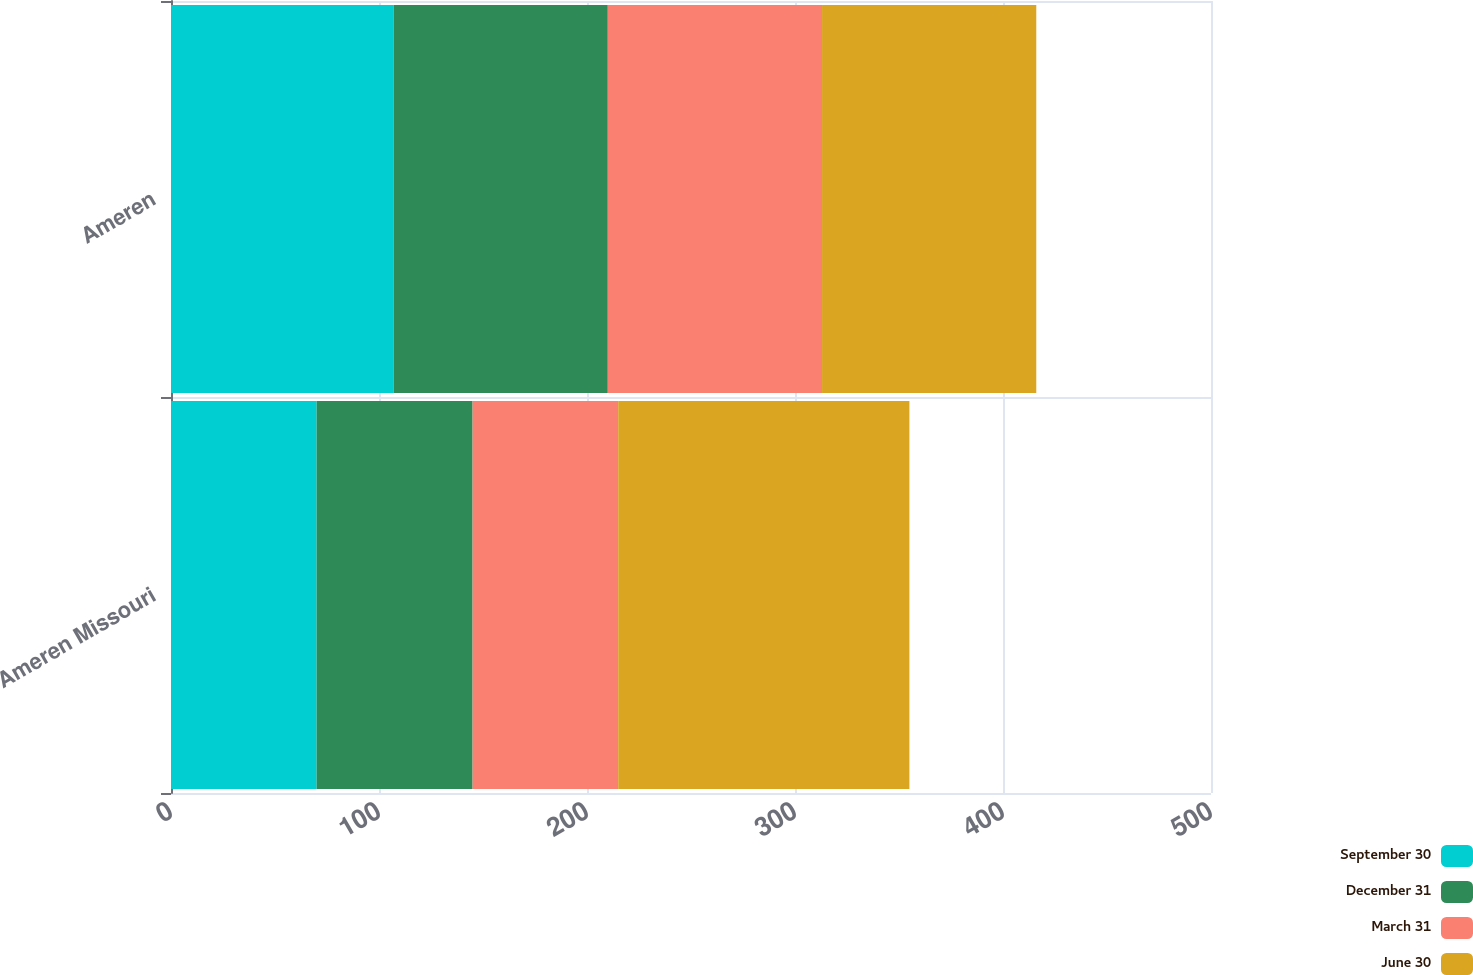<chart> <loc_0><loc_0><loc_500><loc_500><stacked_bar_chart><ecel><fcel>Ameren Missouri<fcel>Ameren<nl><fcel>September 30<fcel>70<fcel>107<nl><fcel>December 31<fcel>75<fcel>103<nl><fcel>March 31<fcel>70<fcel>103<nl><fcel>June 30<fcel>140<fcel>103<nl></chart> 